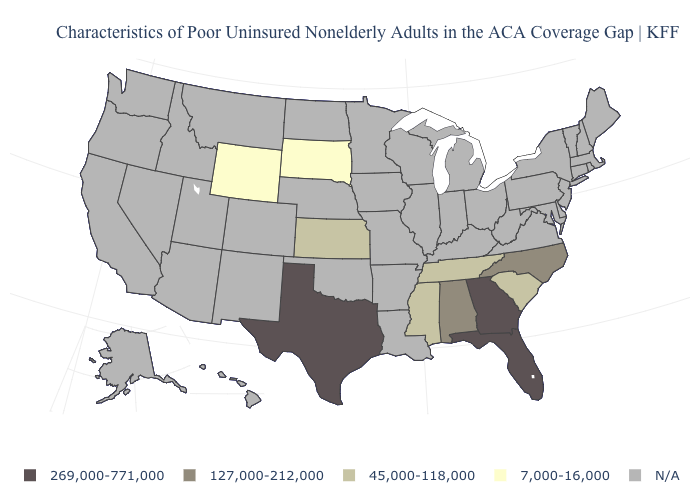Does Tennessee have the lowest value in the South?
Quick response, please. Yes. What is the value of Montana?
Concise answer only. N/A. Which states have the lowest value in the West?
Short answer required. Wyoming. What is the value of Oklahoma?
Give a very brief answer. N/A. Name the states that have a value in the range 127,000-212,000?
Short answer required. Alabama, North Carolina. Does South Carolina have the lowest value in the South?
Write a very short answer. Yes. What is the highest value in the USA?
Answer briefly. 269,000-771,000. What is the value of Rhode Island?
Be succinct. N/A. Which states hav the highest value in the MidWest?
Short answer required. Kansas. What is the value of Delaware?
Quick response, please. N/A. Name the states that have a value in the range 127,000-212,000?
Answer briefly. Alabama, North Carolina. What is the value of Nebraska?
Keep it brief. N/A. What is the value of Idaho?
Keep it brief. N/A. 